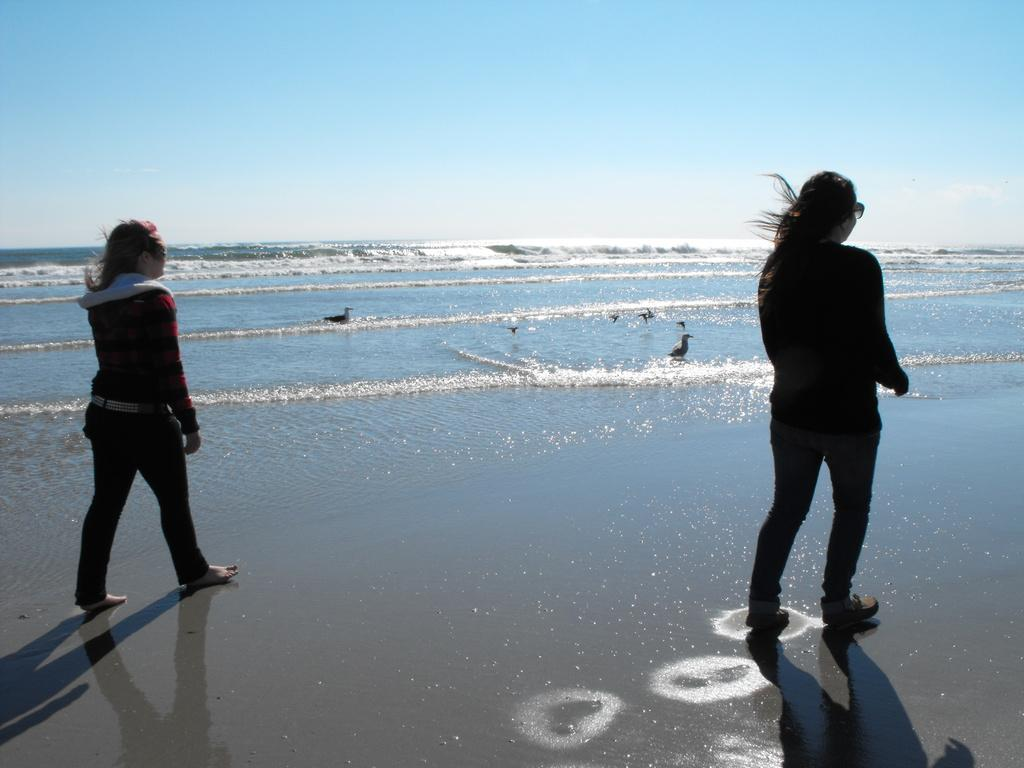How many people are in the image? There are two people in the image. What are the people doing in the image? The people are walking on the beach. What can be seen in the background of the image? There is water visible in the image. What animals are present in the water? There are birds in the water. Can you see a person blowing bubbles in the image? There is no person blowing bubbles in the image. Is there a window visible in the image? There is no window present in the image. 